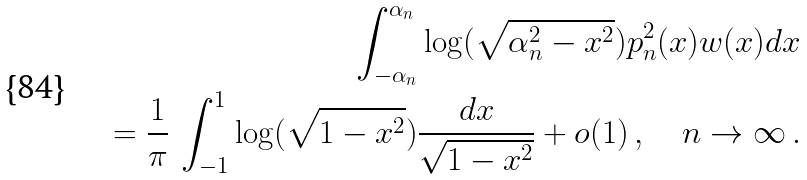Convert formula to latex. <formula><loc_0><loc_0><loc_500><loc_500>\int _ { - \alpha _ { n } } ^ { \alpha _ { n } } \log ( \sqrt { \alpha _ { n } ^ { 2 } - x ^ { 2 } } ) p _ { n } ^ { 2 } ( x ) w ( x ) d x \\ = \frac { 1 } { \pi } \, \int _ { - 1 } ^ { 1 } \log ( \sqrt { 1 - x ^ { 2 } } ) \frac { d x } { \sqrt { 1 - x ^ { 2 } } } + o ( 1 ) \, , \quad n \to \infty \, .</formula> 